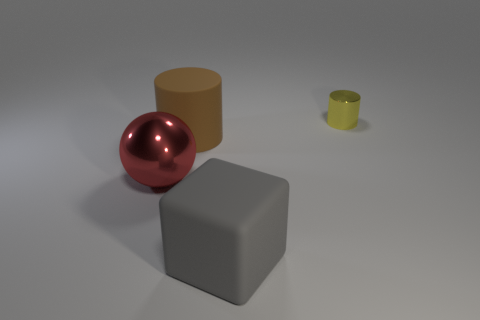Are there any other things that have the same size as the yellow cylinder?
Offer a terse response. No. What is the size of the yellow object that is behind the shiny thing that is to the left of the rubber object that is in front of the brown matte object?
Ensure brevity in your answer.  Small. What number of small things are the same material as the big red ball?
Your answer should be compact. 1. How many gray matte objects are the same size as the yellow cylinder?
Give a very brief answer. 0. What is the material of the big thing on the right side of the big matte thing that is to the left of the big matte object in front of the red thing?
Provide a short and direct response. Rubber. How many things are either matte things or big red shiny things?
Offer a very short reply. 3. What is the shape of the brown rubber object?
Your response must be concise. Cylinder. The object behind the large rubber object on the left side of the gray thing is what shape?
Your answer should be compact. Cylinder. Do the cylinder that is on the left side of the large gray matte block and the tiny yellow thing have the same material?
Offer a terse response. No. How many yellow objects are tiny metal cylinders or blocks?
Make the answer very short. 1. 